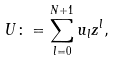Convert formula to latex. <formula><loc_0><loc_0><loc_500><loc_500>U \colon = \sum ^ { N + 1 } _ { l = 0 } u _ { l } z ^ { l } ,</formula> 